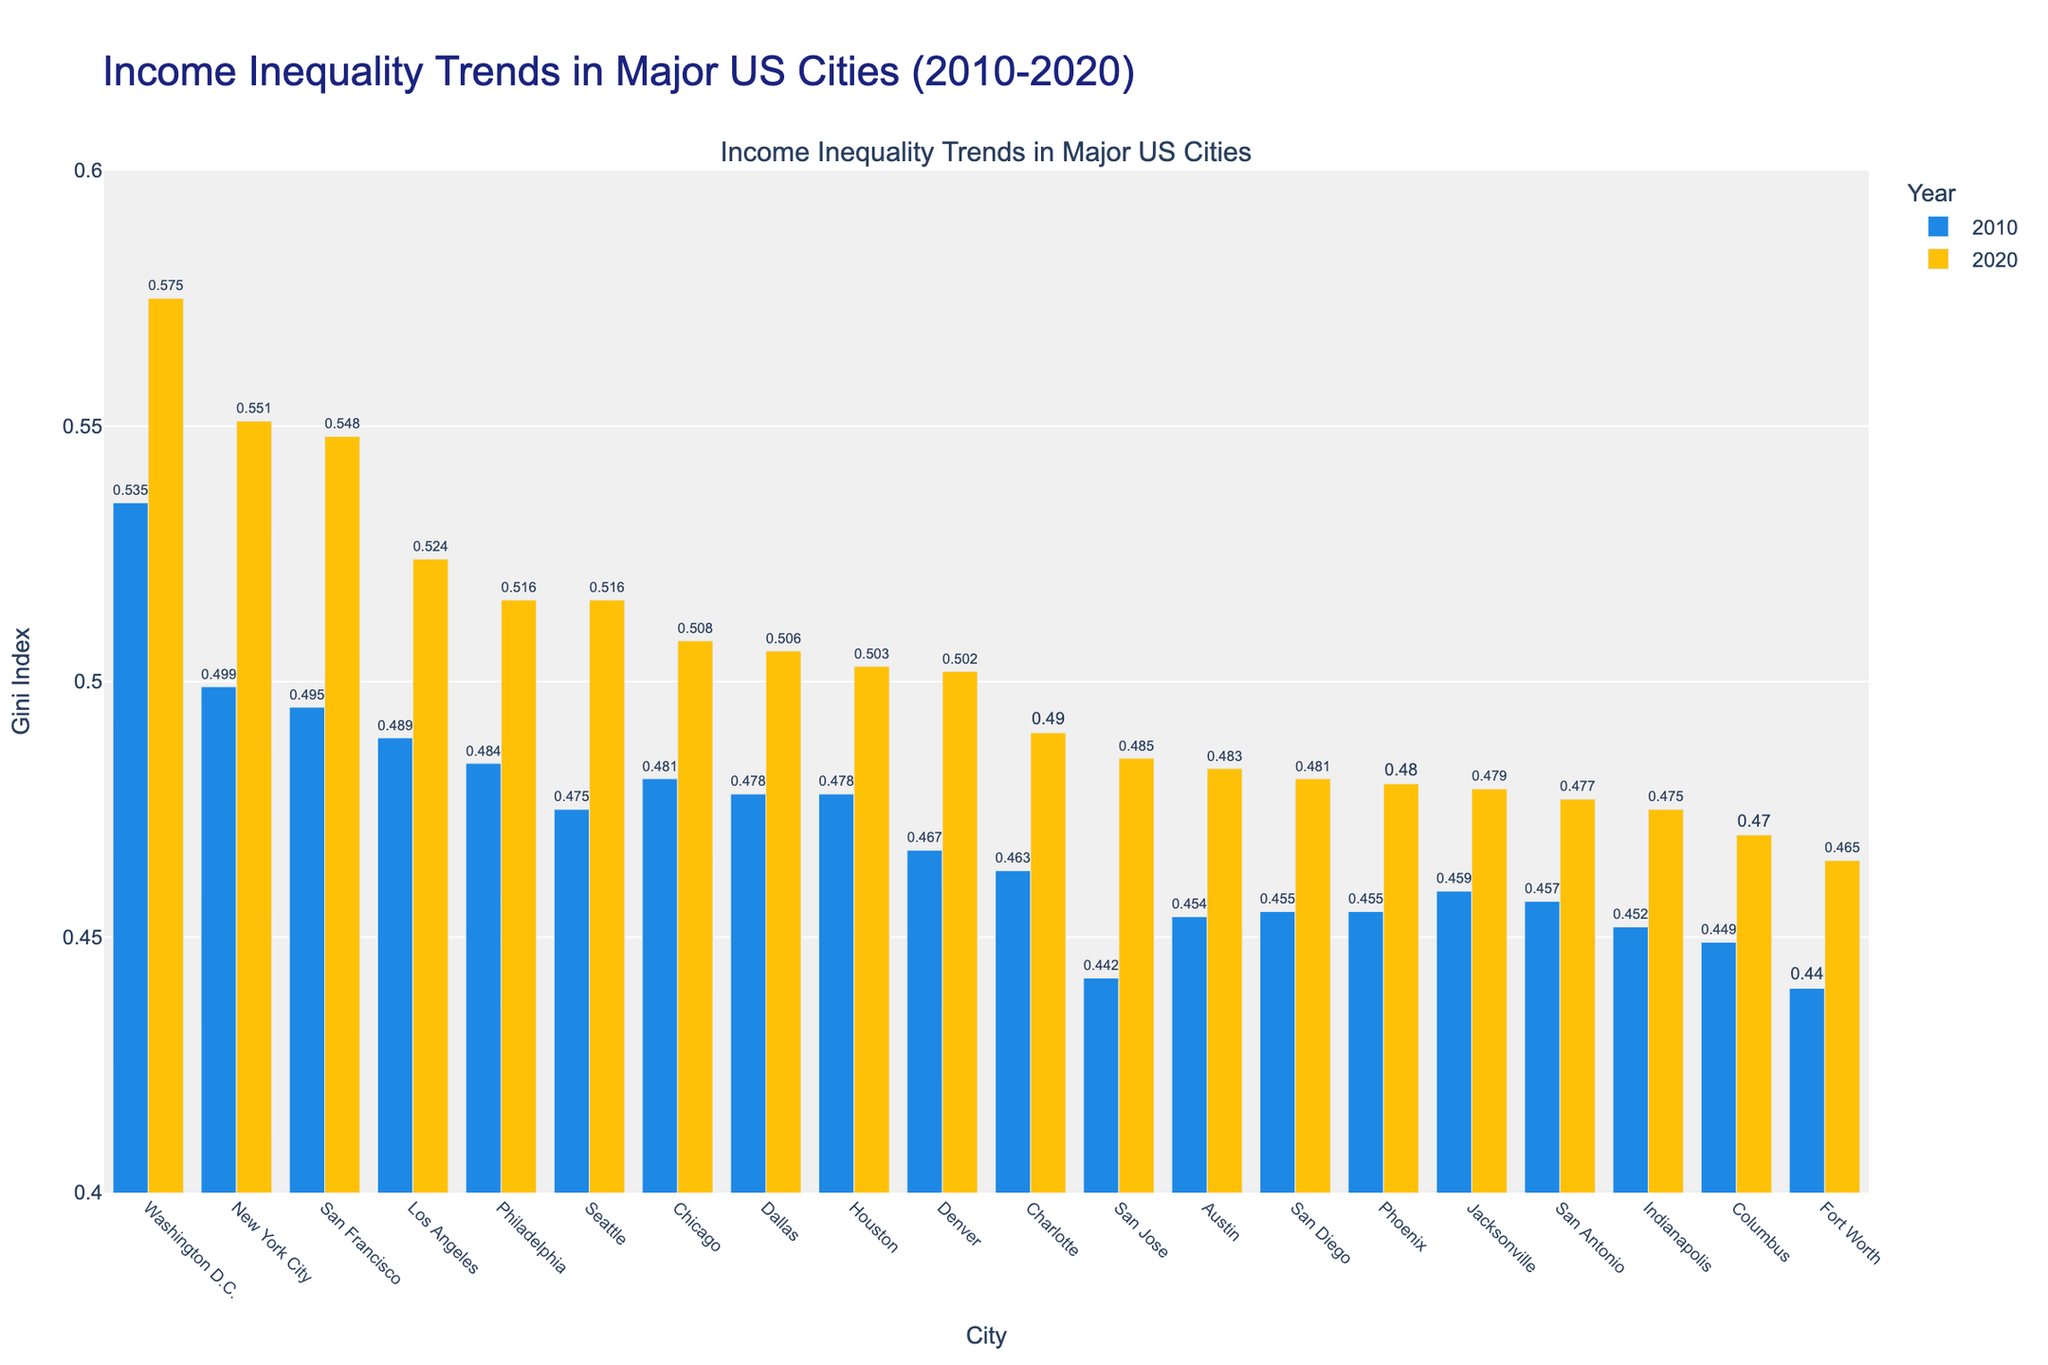What city has the highest Gini Index in 2020 and what was the value? The 2020 Gini Indexes are displayed for all cities. Washington D.C. has the highest value at 0.575.
Answer: Washington D.C., 0.575 Which city showed the biggest increase in Gini Index from 2010 to 2020? For each city, subtract the 2010 Gini Index from the 2020 Gini Index. Washington D.C. has the largest increase (0.575 - 0.535 = 0.04).
Answer: Washington D.C Compare the Gini Index of New York City in 2010 and 2020. Which year had a higher value and by how much? Subtract the 2010 value from the 2020 value for New York City (0.551 - 0.499 = 0.052). The index is higher in 2020 by 0.052.
Answer: 2020 by 0.052 How many cities had a Gini Index higher than 0.5 in 2020? Identify cities with a 2020 Gini Index greater than 0.5: New York City, Los Angeles, Philadelphia, Seattle, Washington D.C., and San Francisco. There are 6 cities in total.
Answer: 6 What is the average Gini Index across all cities for 2020? Sum the 2020 Gini Index values for all cities and divide by the number of cities (8.227 / 19).
Answer: 0.433 Which city has the smallest Gini Index increase from 2010 to 2020? Calculate the difference for each city and find the smallest positive difference. Fort Worth had the smallest increase (0.465 - 0.440 = 0.015).
Answer: Fort Worth In which city did income inequality (measured by the Gini Index) increase the least between 2010 and 2020? Subtract the 2010 Gini Index from the 2020 Gini Index for each city. Fort Worth had the smallest increase at 0.025 (from 0.440 to 0.465).
Answer: Fort Worth Compare the Gini Index for Phoenix in 2010 and 2020. Did it increase or decrease, and by how much? Subtract the 2010 Gini Index from the 2020 Gini Index for Phoenix (0.480 - 0.455 = 0.025). The Gini Index increased by 0.025.
Answer: increased by 0.025 